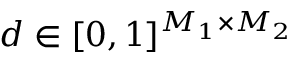Convert formula to latex. <formula><loc_0><loc_0><loc_500><loc_500>d \in [ 0 , 1 ] ^ { M _ { 1 } \times M _ { 2 } }</formula> 